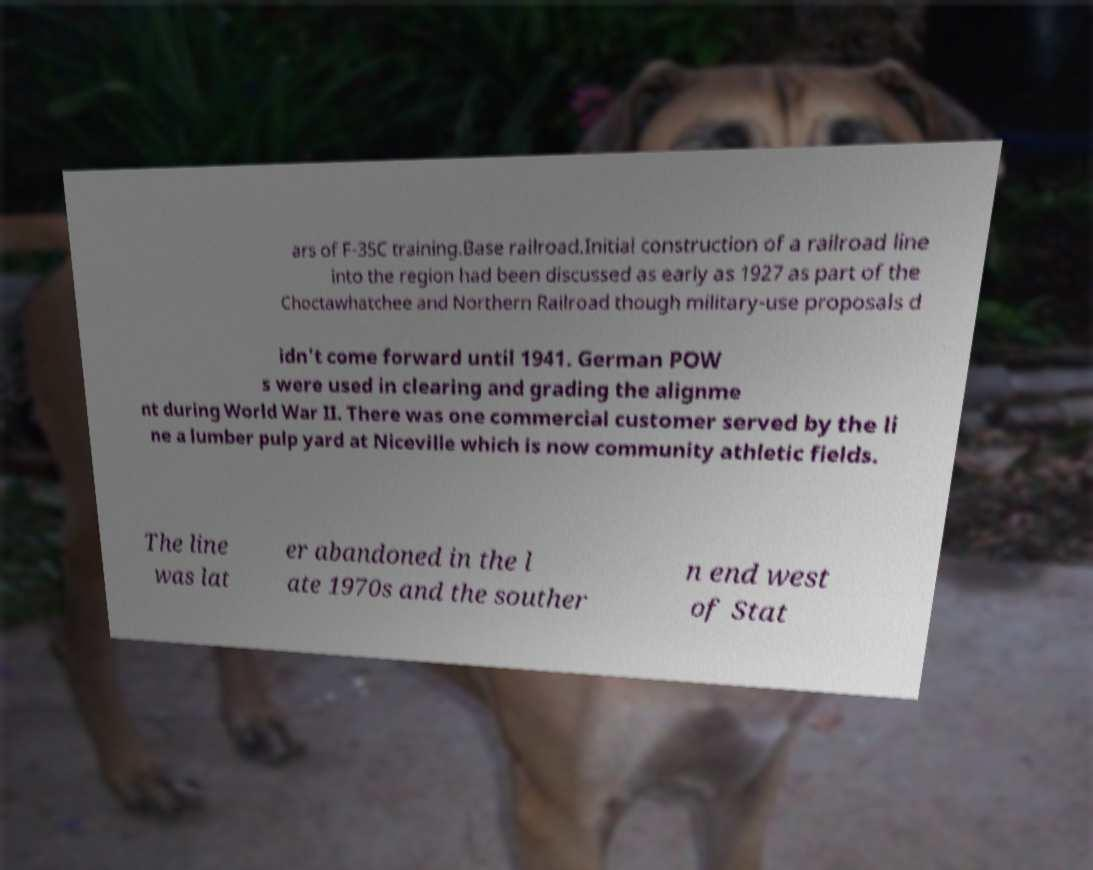Can you accurately transcribe the text from the provided image for me? ars of F-35C training.Base railroad.Initial construction of a railroad line into the region had been discussed as early as 1927 as part of the Choctawhatchee and Northern Railroad though military-use proposals d idn't come forward until 1941. German POW s were used in clearing and grading the alignme nt during World War II. There was one commercial customer served by the li ne a lumber pulp yard at Niceville which is now community athletic fields. The line was lat er abandoned in the l ate 1970s and the souther n end west of Stat 